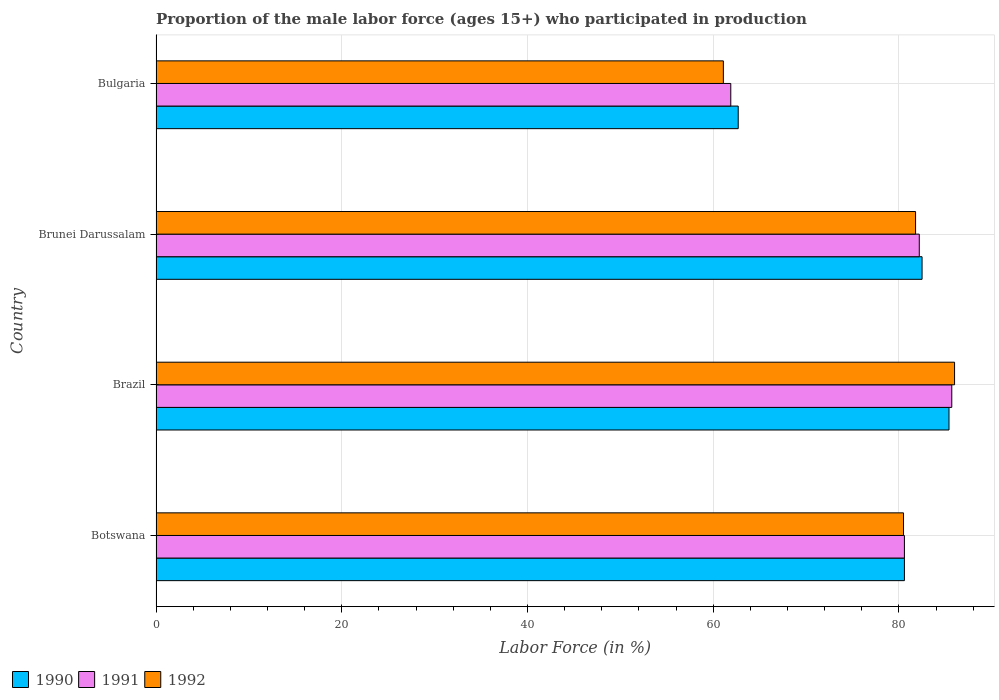In how many cases, is the number of bars for a given country not equal to the number of legend labels?
Give a very brief answer. 0. What is the proportion of the male labor force who participated in production in 1990 in Brunei Darussalam?
Ensure brevity in your answer.  82.5. Across all countries, what is the maximum proportion of the male labor force who participated in production in 1990?
Provide a short and direct response. 85.4. Across all countries, what is the minimum proportion of the male labor force who participated in production in 1991?
Your answer should be very brief. 61.9. What is the total proportion of the male labor force who participated in production in 1991 in the graph?
Your response must be concise. 310.4. What is the difference between the proportion of the male labor force who participated in production in 1990 in Botswana and that in Brazil?
Ensure brevity in your answer.  -4.8. What is the difference between the proportion of the male labor force who participated in production in 1992 in Brunei Darussalam and the proportion of the male labor force who participated in production in 1991 in Brazil?
Make the answer very short. -3.9. What is the average proportion of the male labor force who participated in production in 1990 per country?
Offer a very short reply. 77.8. What is the difference between the proportion of the male labor force who participated in production in 1991 and proportion of the male labor force who participated in production in 1992 in Botswana?
Offer a terse response. 0.1. What is the ratio of the proportion of the male labor force who participated in production in 1992 in Botswana to that in Brazil?
Ensure brevity in your answer.  0.94. Is the difference between the proportion of the male labor force who participated in production in 1991 in Botswana and Bulgaria greater than the difference between the proportion of the male labor force who participated in production in 1992 in Botswana and Bulgaria?
Ensure brevity in your answer.  No. What is the difference between the highest and the second highest proportion of the male labor force who participated in production in 1990?
Provide a succinct answer. 2.9. What is the difference between the highest and the lowest proportion of the male labor force who participated in production in 1990?
Provide a short and direct response. 22.7. In how many countries, is the proportion of the male labor force who participated in production in 1991 greater than the average proportion of the male labor force who participated in production in 1991 taken over all countries?
Your answer should be very brief. 3. What does the 1st bar from the bottom in Botswana represents?
Give a very brief answer. 1990. Does the graph contain grids?
Keep it short and to the point. Yes. What is the title of the graph?
Give a very brief answer. Proportion of the male labor force (ages 15+) who participated in production. Does "1996" appear as one of the legend labels in the graph?
Your answer should be compact. No. What is the label or title of the X-axis?
Give a very brief answer. Labor Force (in %). What is the Labor Force (in %) in 1990 in Botswana?
Ensure brevity in your answer.  80.6. What is the Labor Force (in %) of 1991 in Botswana?
Give a very brief answer. 80.6. What is the Labor Force (in %) of 1992 in Botswana?
Your answer should be very brief. 80.5. What is the Labor Force (in %) in 1990 in Brazil?
Make the answer very short. 85.4. What is the Labor Force (in %) of 1991 in Brazil?
Provide a succinct answer. 85.7. What is the Labor Force (in %) of 1992 in Brazil?
Give a very brief answer. 86. What is the Labor Force (in %) in 1990 in Brunei Darussalam?
Make the answer very short. 82.5. What is the Labor Force (in %) of 1991 in Brunei Darussalam?
Make the answer very short. 82.2. What is the Labor Force (in %) of 1992 in Brunei Darussalam?
Make the answer very short. 81.8. What is the Labor Force (in %) of 1990 in Bulgaria?
Provide a succinct answer. 62.7. What is the Labor Force (in %) in 1991 in Bulgaria?
Make the answer very short. 61.9. What is the Labor Force (in %) in 1992 in Bulgaria?
Your response must be concise. 61.1. Across all countries, what is the maximum Labor Force (in %) in 1990?
Your answer should be compact. 85.4. Across all countries, what is the maximum Labor Force (in %) in 1991?
Provide a succinct answer. 85.7. Across all countries, what is the maximum Labor Force (in %) in 1992?
Your response must be concise. 86. Across all countries, what is the minimum Labor Force (in %) in 1990?
Ensure brevity in your answer.  62.7. Across all countries, what is the minimum Labor Force (in %) of 1991?
Your answer should be compact. 61.9. Across all countries, what is the minimum Labor Force (in %) in 1992?
Your answer should be very brief. 61.1. What is the total Labor Force (in %) of 1990 in the graph?
Keep it short and to the point. 311.2. What is the total Labor Force (in %) in 1991 in the graph?
Give a very brief answer. 310.4. What is the total Labor Force (in %) of 1992 in the graph?
Give a very brief answer. 309.4. What is the difference between the Labor Force (in %) of 1990 in Botswana and that in Brazil?
Your response must be concise. -4.8. What is the difference between the Labor Force (in %) in 1990 in Botswana and that in Brunei Darussalam?
Offer a very short reply. -1.9. What is the difference between the Labor Force (in %) in 1992 in Botswana and that in Brunei Darussalam?
Make the answer very short. -1.3. What is the difference between the Labor Force (in %) of 1992 in Botswana and that in Bulgaria?
Offer a terse response. 19.4. What is the difference between the Labor Force (in %) in 1991 in Brazil and that in Brunei Darussalam?
Provide a succinct answer. 3.5. What is the difference between the Labor Force (in %) in 1992 in Brazil and that in Brunei Darussalam?
Provide a short and direct response. 4.2. What is the difference between the Labor Force (in %) of 1990 in Brazil and that in Bulgaria?
Your answer should be compact. 22.7. What is the difference between the Labor Force (in %) in 1991 in Brazil and that in Bulgaria?
Your answer should be compact. 23.8. What is the difference between the Labor Force (in %) in 1992 in Brazil and that in Bulgaria?
Make the answer very short. 24.9. What is the difference between the Labor Force (in %) of 1990 in Brunei Darussalam and that in Bulgaria?
Give a very brief answer. 19.8. What is the difference between the Labor Force (in %) of 1991 in Brunei Darussalam and that in Bulgaria?
Offer a terse response. 20.3. What is the difference between the Labor Force (in %) of 1992 in Brunei Darussalam and that in Bulgaria?
Your answer should be very brief. 20.7. What is the difference between the Labor Force (in %) in 1991 in Botswana and the Labor Force (in %) in 1992 in Brunei Darussalam?
Ensure brevity in your answer.  -1.2. What is the difference between the Labor Force (in %) of 1990 in Botswana and the Labor Force (in %) of 1991 in Bulgaria?
Your answer should be compact. 18.7. What is the difference between the Labor Force (in %) of 1991 in Botswana and the Labor Force (in %) of 1992 in Bulgaria?
Provide a short and direct response. 19.5. What is the difference between the Labor Force (in %) of 1990 in Brazil and the Labor Force (in %) of 1991 in Brunei Darussalam?
Provide a succinct answer. 3.2. What is the difference between the Labor Force (in %) of 1991 in Brazil and the Labor Force (in %) of 1992 in Brunei Darussalam?
Offer a terse response. 3.9. What is the difference between the Labor Force (in %) of 1990 in Brazil and the Labor Force (in %) of 1992 in Bulgaria?
Provide a succinct answer. 24.3. What is the difference between the Labor Force (in %) in 1991 in Brazil and the Labor Force (in %) in 1992 in Bulgaria?
Provide a short and direct response. 24.6. What is the difference between the Labor Force (in %) of 1990 in Brunei Darussalam and the Labor Force (in %) of 1991 in Bulgaria?
Ensure brevity in your answer.  20.6. What is the difference between the Labor Force (in %) of 1990 in Brunei Darussalam and the Labor Force (in %) of 1992 in Bulgaria?
Keep it short and to the point. 21.4. What is the difference between the Labor Force (in %) of 1991 in Brunei Darussalam and the Labor Force (in %) of 1992 in Bulgaria?
Your answer should be compact. 21.1. What is the average Labor Force (in %) in 1990 per country?
Make the answer very short. 77.8. What is the average Labor Force (in %) of 1991 per country?
Provide a short and direct response. 77.6. What is the average Labor Force (in %) in 1992 per country?
Provide a short and direct response. 77.35. What is the difference between the Labor Force (in %) in 1990 and Labor Force (in %) in 1991 in Botswana?
Give a very brief answer. 0. What is the difference between the Labor Force (in %) of 1991 and Labor Force (in %) of 1992 in Botswana?
Provide a succinct answer. 0.1. What is the difference between the Labor Force (in %) in 1990 and Labor Force (in %) in 1992 in Brunei Darussalam?
Offer a very short reply. 0.7. What is the ratio of the Labor Force (in %) of 1990 in Botswana to that in Brazil?
Offer a terse response. 0.94. What is the ratio of the Labor Force (in %) in 1991 in Botswana to that in Brazil?
Provide a short and direct response. 0.94. What is the ratio of the Labor Force (in %) in 1992 in Botswana to that in Brazil?
Provide a succinct answer. 0.94. What is the ratio of the Labor Force (in %) of 1991 in Botswana to that in Brunei Darussalam?
Give a very brief answer. 0.98. What is the ratio of the Labor Force (in %) of 1992 in Botswana to that in Brunei Darussalam?
Offer a terse response. 0.98. What is the ratio of the Labor Force (in %) of 1990 in Botswana to that in Bulgaria?
Make the answer very short. 1.29. What is the ratio of the Labor Force (in %) of 1991 in Botswana to that in Bulgaria?
Offer a terse response. 1.3. What is the ratio of the Labor Force (in %) in 1992 in Botswana to that in Bulgaria?
Offer a terse response. 1.32. What is the ratio of the Labor Force (in %) in 1990 in Brazil to that in Brunei Darussalam?
Offer a terse response. 1.04. What is the ratio of the Labor Force (in %) in 1991 in Brazil to that in Brunei Darussalam?
Your answer should be very brief. 1.04. What is the ratio of the Labor Force (in %) of 1992 in Brazil to that in Brunei Darussalam?
Make the answer very short. 1.05. What is the ratio of the Labor Force (in %) of 1990 in Brazil to that in Bulgaria?
Make the answer very short. 1.36. What is the ratio of the Labor Force (in %) in 1991 in Brazil to that in Bulgaria?
Offer a very short reply. 1.38. What is the ratio of the Labor Force (in %) in 1992 in Brazil to that in Bulgaria?
Make the answer very short. 1.41. What is the ratio of the Labor Force (in %) of 1990 in Brunei Darussalam to that in Bulgaria?
Give a very brief answer. 1.32. What is the ratio of the Labor Force (in %) of 1991 in Brunei Darussalam to that in Bulgaria?
Offer a very short reply. 1.33. What is the ratio of the Labor Force (in %) in 1992 in Brunei Darussalam to that in Bulgaria?
Your answer should be very brief. 1.34. What is the difference between the highest and the second highest Labor Force (in %) in 1990?
Offer a very short reply. 2.9. What is the difference between the highest and the second highest Labor Force (in %) in 1991?
Your answer should be compact. 3.5. What is the difference between the highest and the second highest Labor Force (in %) in 1992?
Provide a short and direct response. 4.2. What is the difference between the highest and the lowest Labor Force (in %) in 1990?
Keep it short and to the point. 22.7. What is the difference between the highest and the lowest Labor Force (in %) in 1991?
Provide a succinct answer. 23.8. What is the difference between the highest and the lowest Labor Force (in %) in 1992?
Your answer should be very brief. 24.9. 